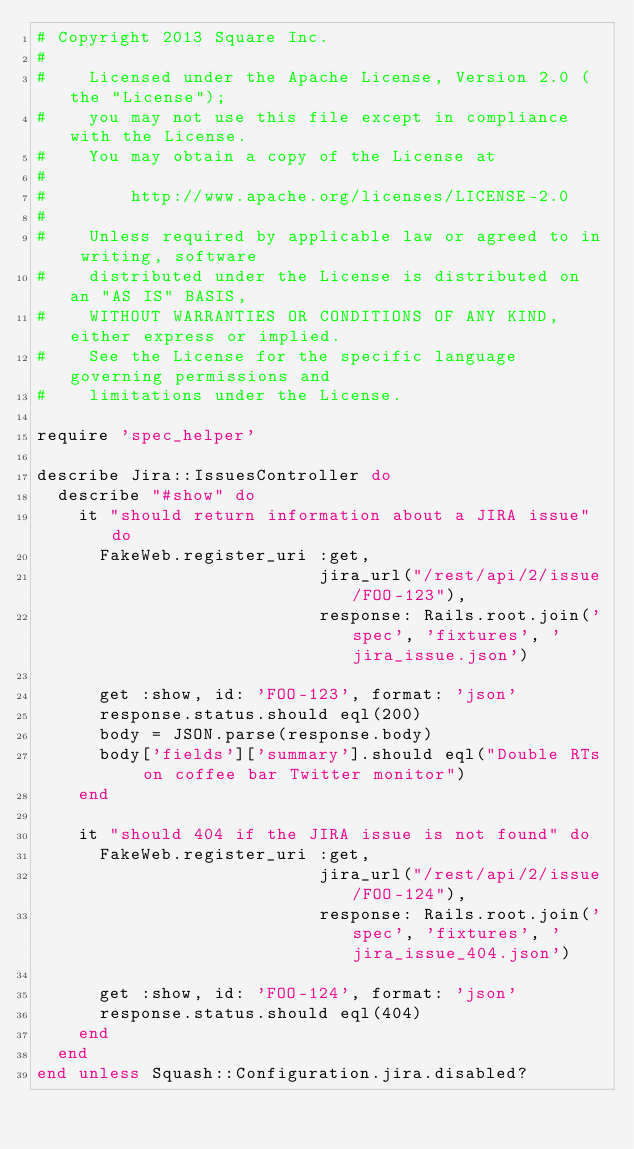<code> <loc_0><loc_0><loc_500><loc_500><_Ruby_># Copyright 2013 Square Inc.
#
#    Licensed under the Apache License, Version 2.0 (the "License");
#    you may not use this file except in compliance with the License.
#    You may obtain a copy of the License at
#
#        http://www.apache.org/licenses/LICENSE-2.0
#
#    Unless required by applicable law or agreed to in writing, software
#    distributed under the License is distributed on an "AS IS" BASIS,
#    WITHOUT WARRANTIES OR CONDITIONS OF ANY KIND, either express or implied.
#    See the License for the specific language governing permissions and
#    limitations under the License.

require 'spec_helper'

describe Jira::IssuesController do
  describe "#show" do
    it "should return information about a JIRA issue" do
      FakeWeb.register_uri :get,
                           jira_url("/rest/api/2/issue/FOO-123"),
                           response: Rails.root.join('spec', 'fixtures', 'jira_issue.json')

      get :show, id: 'FOO-123', format: 'json'
      response.status.should eql(200)
      body = JSON.parse(response.body)
      body['fields']['summary'].should eql("Double RTs on coffee bar Twitter monitor")
    end

    it "should 404 if the JIRA issue is not found" do
      FakeWeb.register_uri :get,
                           jira_url("/rest/api/2/issue/FOO-124"),
                           response: Rails.root.join('spec', 'fixtures', 'jira_issue_404.json')

      get :show, id: 'FOO-124', format: 'json'
      response.status.should eql(404)
    end
  end
end unless Squash::Configuration.jira.disabled?
</code> 